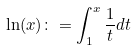<formula> <loc_0><loc_0><loc_500><loc_500>\ln ( x ) \colon = \int _ { 1 } ^ { x } \frac { 1 } { t } d t</formula> 